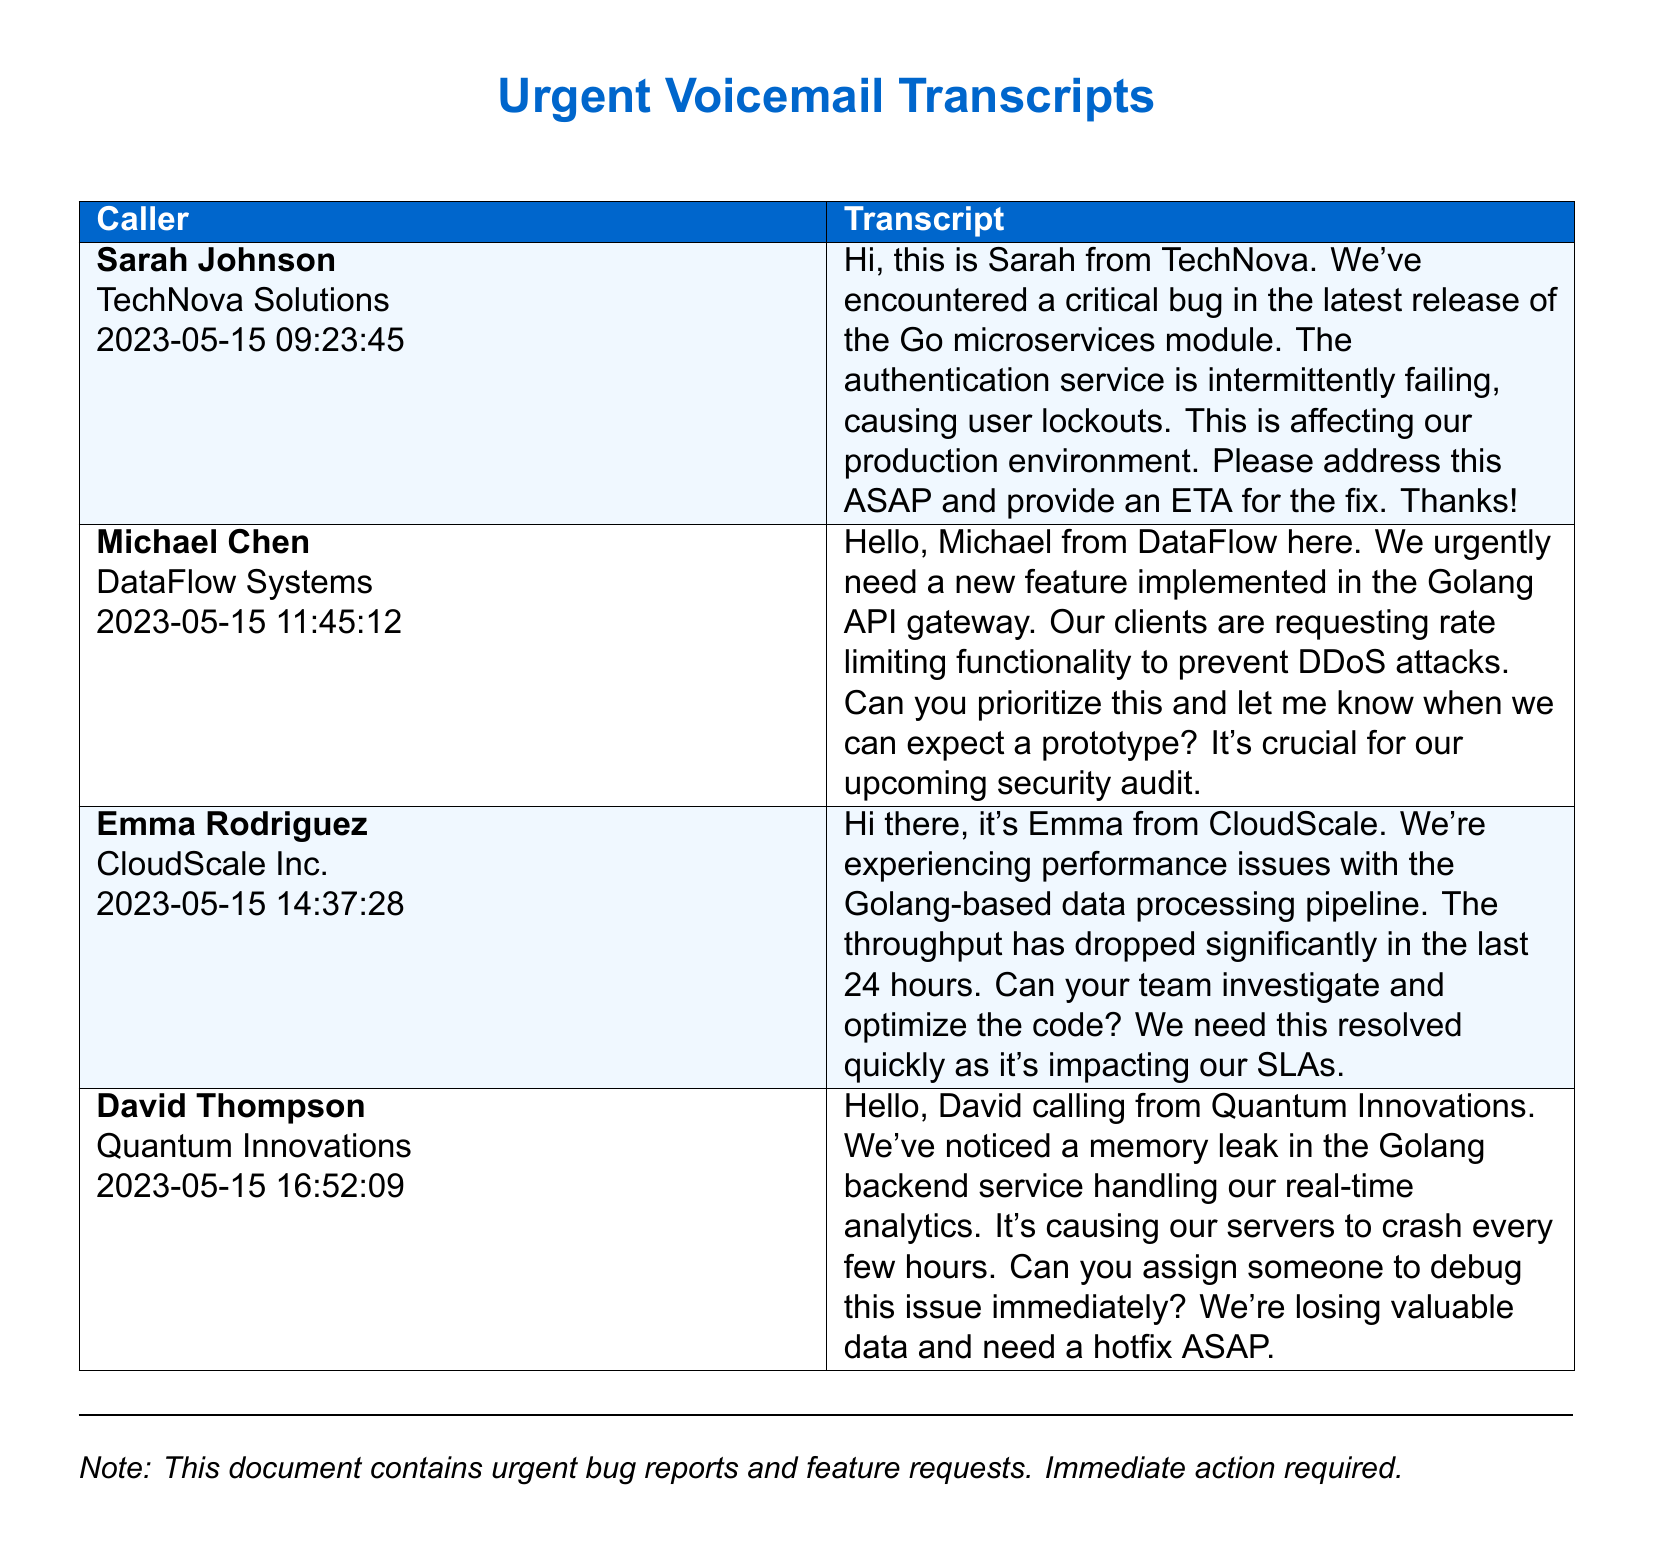What is the name of the first caller? The first caller is mentioned at the top of the document and is identified as Sarah Johnson from TechNova Solutions.
Answer: Sarah Johnson What company does Michael Chen represent? The document states that Michael Chen is calling from DataFlow Systems.
Answer: DataFlow Systems What issue is mentioned in Sarah Johnson's transcript? Sarah mentions a critical bug in the Go microservices module that is causing user lockouts.
Answer: Critical bug When did Emma Rodriguez make her call? The date and time of Emma Rodriguez's call are indicated in the document as 2023-05-15 14:37:28.
Answer: 2023-05-15 14:37:28 What specific feature is requested by Michael Chen? Michael asks for the implementation of rate limiting functionality in the Golang API gateway.
Answer: Rate limiting functionality How many callers reported urgent issues? The document lists four callers who reported urgent issues.
Answer: Four What is the nature of the issue reported by David Thompson? David reports a memory leak in the Golang backend service causing server crashes.
Answer: Memory leak What is the urgency of the requests in this document? The document notes that these reports are labeled as urgent and requiring immediate action.
Answer: Urgent What is the common technology referenced in the voicemail transcripts? All the transcripts involve issues or requests related to Golang technology.
Answer: Golang 